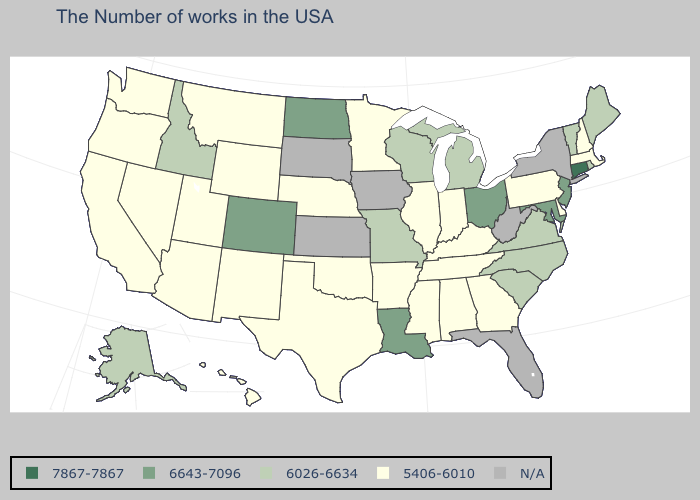What is the lowest value in the USA?
Write a very short answer. 5406-6010. Which states have the highest value in the USA?
Keep it brief. Connecticut. Which states have the highest value in the USA?
Be succinct. Connecticut. Does Maryland have the lowest value in the South?
Answer briefly. No. Which states have the lowest value in the USA?
Concise answer only. Massachusetts, New Hampshire, Delaware, Pennsylvania, Georgia, Kentucky, Indiana, Alabama, Tennessee, Illinois, Mississippi, Arkansas, Minnesota, Nebraska, Oklahoma, Texas, Wyoming, New Mexico, Utah, Montana, Arizona, Nevada, California, Washington, Oregon, Hawaii. What is the highest value in states that border Delaware?
Write a very short answer. 6643-7096. Name the states that have a value in the range 5406-6010?
Short answer required. Massachusetts, New Hampshire, Delaware, Pennsylvania, Georgia, Kentucky, Indiana, Alabama, Tennessee, Illinois, Mississippi, Arkansas, Minnesota, Nebraska, Oklahoma, Texas, Wyoming, New Mexico, Utah, Montana, Arizona, Nevada, California, Washington, Oregon, Hawaii. What is the lowest value in states that border Pennsylvania?
Keep it brief. 5406-6010. How many symbols are there in the legend?
Keep it brief. 5. What is the lowest value in the South?
Give a very brief answer. 5406-6010. What is the lowest value in states that border Arizona?
Short answer required. 5406-6010. Which states have the highest value in the USA?
Write a very short answer. Connecticut. 